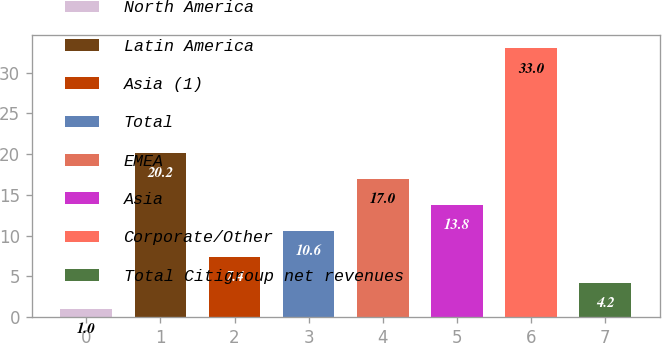<chart> <loc_0><loc_0><loc_500><loc_500><bar_chart><fcel>North America<fcel>Latin America<fcel>Asia (1)<fcel>Total<fcel>EMEA<fcel>Asia<fcel>Corporate/Other<fcel>Total Citigroup net revenues<nl><fcel>1<fcel>20.2<fcel>7.4<fcel>10.6<fcel>17<fcel>13.8<fcel>33<fcel>4.2<nl></chart> 